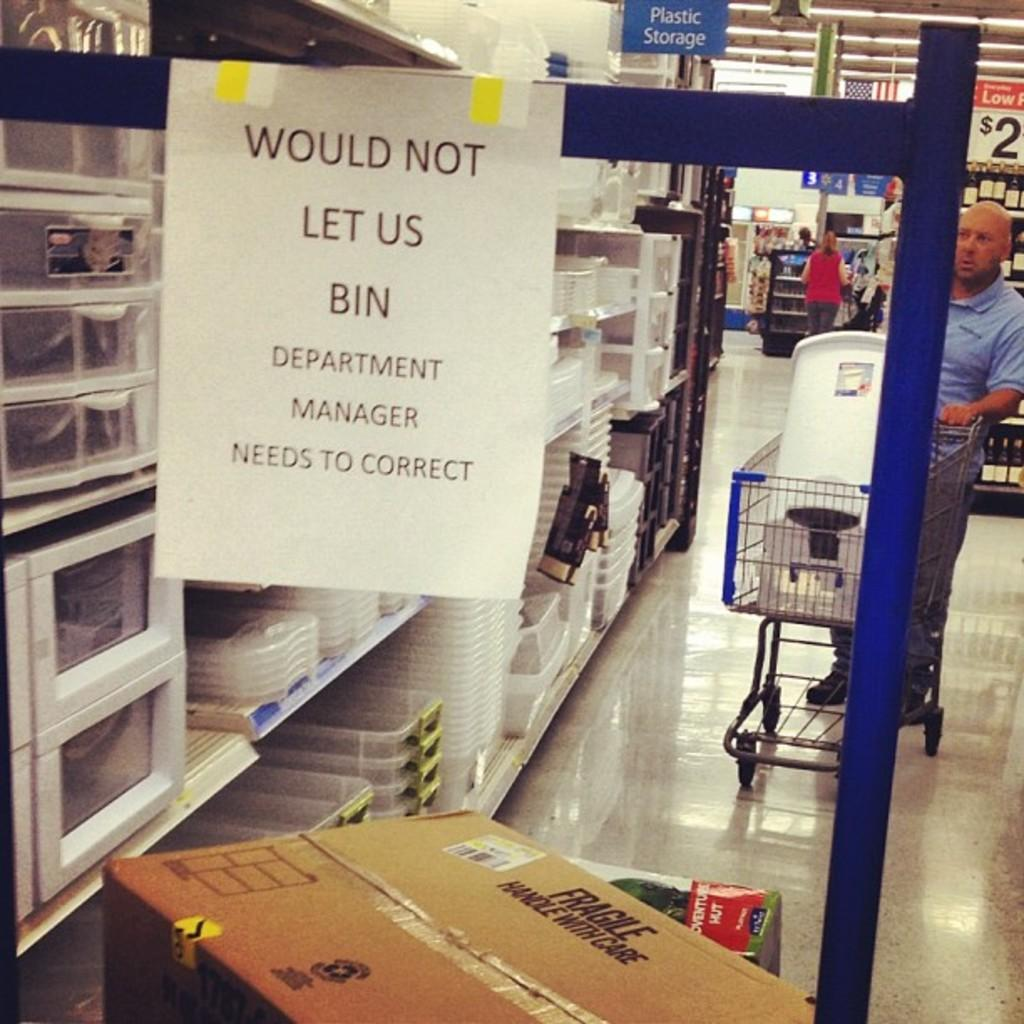Provide a one-sentence caption for the provided image. A sign hangs from a cart that says, "Would not let us bin.". 